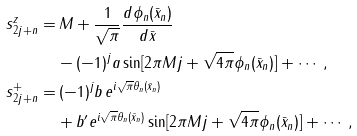Convert formula to latex. <formula><loc_0><loc_0><loc_500><loc_500>s ^ { z } _ { 2 j + n } = & \, M + \frac { 1 } { \sqrt { \pi } } \frac { d \phi _ { n } ( \bar { x } _ { n } ) } { d \bar { x } } \\ & - ( - 1 ) ^ { j } a \sin [ 2 \pi M j + \sqrt { 4 \pi } \phi _ { n } ( \bar { x } _ { n } ) ] + \cdots , \\ s ^ { + } _ { 2 j + n } = & \, ( - 1 ) ^ { j } b \, e ^ { i \sqrt { \pi } \theta _ { n } ( \bar { x } _ { n } ) } \\ & + b ^ { \prime } e ^ { i \sqrt { \pi } \theta _ { n } ( \bar { x } _ { n } ) } \sin [ 2 \pi M j + \sqrt { 4 \pi } \phi _ { n } ( \bar { x } _ { n } ) ] + \cdots , \\</formula> 